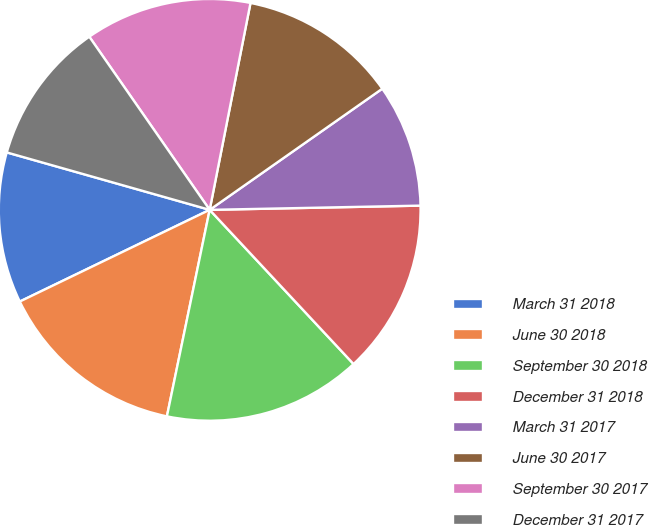Convert chart. <chart><loc_0><loc_0><loc_500><loc_500><pie_chart><fcel>March 31 2018<fcel>June 30 2018<fcel>September 30 2018<fcel>December 31 2018<fcel>March 31 2017<fcel>June 30 2017<fcel>September 30 2017<fcel>December 31 2017<nl><fcel>11.55%<fcel>14.59%<fcel>15.2%<fcel>13.37%<fcel>9.42%<fcel>12.16%<fcel>12.77%<fcel>10.94%<nl></chart> 